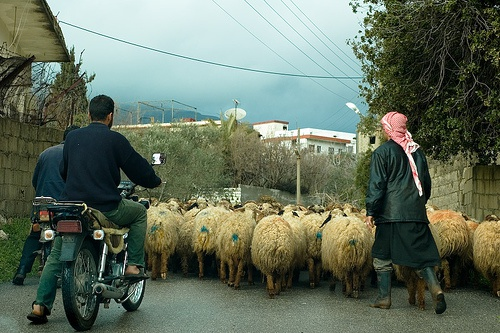Describe the objects in this image and their specific colors. I can see people in olive, black, teal, gray, and darkgreen tones, people in olive, black, darkgreen, and gray tones, motorcycle in olive, black, gray, teal, and darkgreen tones, sheep in olive, black, tan, and khaki tones, and sheep in olive, tan, black, and khaki tones in this image. 